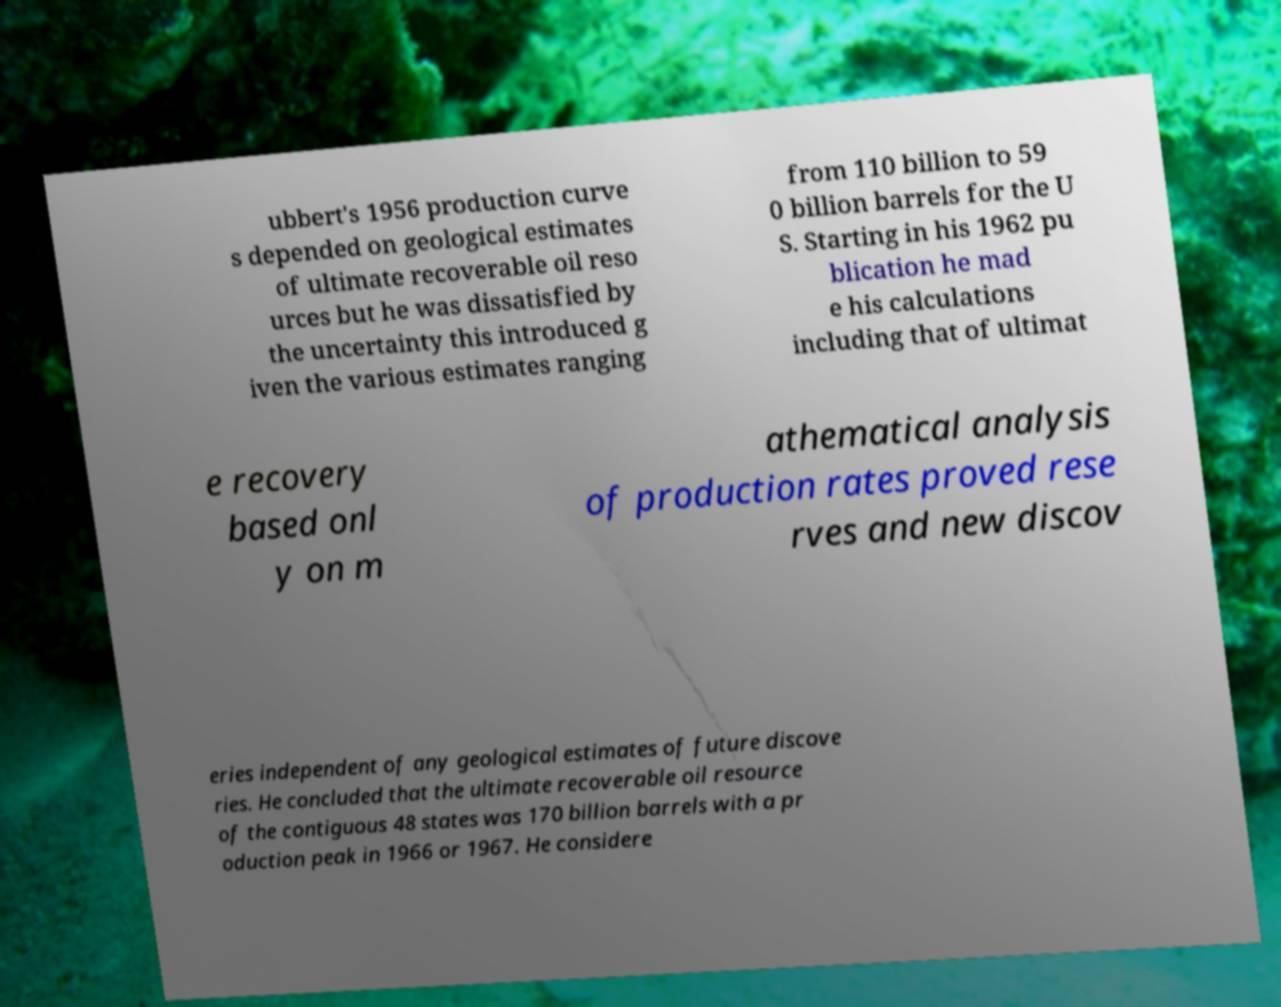Please identify and transcribe the text found in this image. ubbert's 1956 production curve s depended on geological estimates of ultimate recoverable oil reso urces but he was dissatisfied by the uncertainty this introduced g iven the various estimates ranging from 110 billion to 59 0 billion barrels for the U S. Starting in his 1962 pu blication he mad e his calculations including that of ultimat e recovery based onl y on m athematical analysis of production rates proved rese rves and new discov eries independent of any geological estimates of future discove ries. He concluded that the ultimate recoverable oil resource of the contiguous 48 states was 170 billion barrels with a pr oduction peak in 1966 or 1967. He considere 